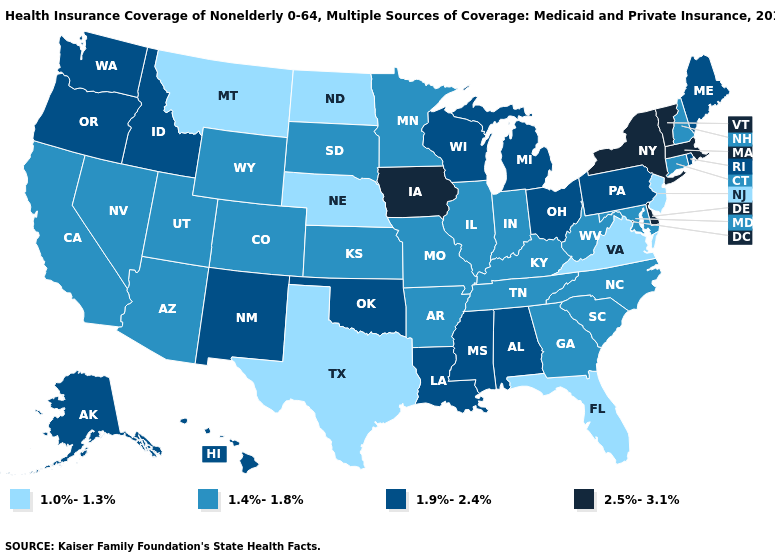How many symbols are there in the legend?
Keep it brief. 4. Does the first symbol in the legend represent the smallest category?
Answer briefly. Yes. Does Delaware have the highest value in the South?
Short answer required. Yes. What is the value of Wyoming?
Keep it brief. 1.4%-1.8%. Which states have the lowest value in the West?
Quick response, please. Montana. What is the value of New Mexico?
Short answer required. 1.9%-2.4%. Name the states that have a value in the range 1.0%-1.3%?
Be succinct. Florida, Montana, Nebraska, New Jersey, North Dakota, Texas, Virginia. How many symbols are there in the legend?
Quick response, please. 4. Among the states that border Iowa , does Wisconsin have the highest value?
Write a very short answer. Yes. What is the lowest value in the Northeast?
Give a very brief answer. 1.0%-1.3%. Does the first symbol in the legend represent the smallest category?
Keep it brief. Yes. Does Oklahoma have the same value as Alabama?
Concise answer only. Yes. Name the states that have a value in the range 2.5%-3.1%?
Give a very brief answer. Delaware, Iowa, Massachusetts, New York, Vermont. Does Kentucky have the lowest value in the South?
Give a very brief answer. No. Does Vermont have the highest value in the USA?
Keep it brief. Yes. 